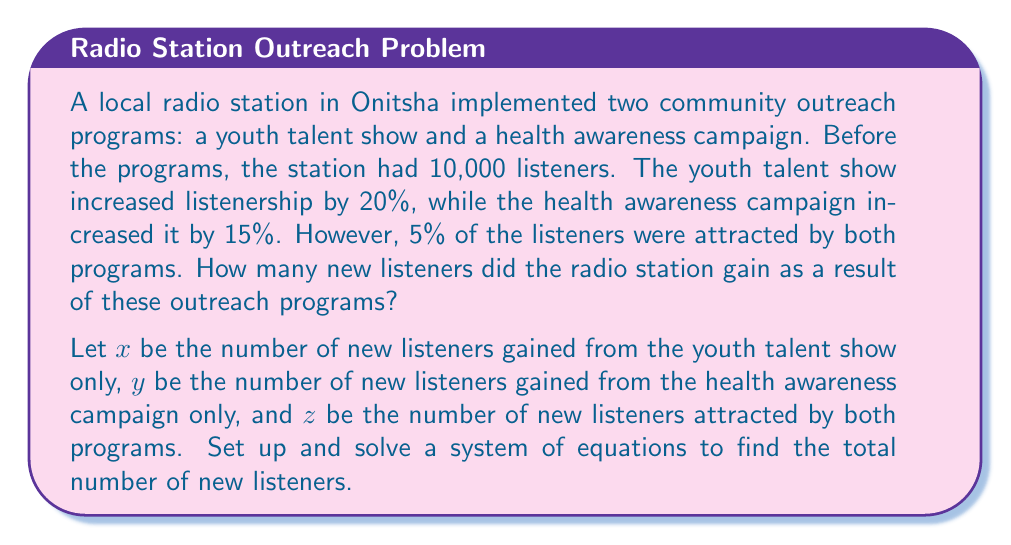Show me your answer to this math problem. Let's approach this problem step by step:

1) First, let's set up our equations based on the given information:

   $x + z = 0.20 \times 10,000 = 2,000$ (Youth talent show)
   $y + z = 0.15 \times 10,000 = 1,500$ (Health awareness campaign)
   $z = 0.05 \times 10,000 = 500$ (Listeners attracted by both programs)

2) Now we have a system of three equations with three unknowns:

   $$\begin{cases}
   x + z = 2,000 \\
   y + z = 1,500 \\
   z = 500
   \end{cases}$$

3) We can solve this system by substitution. Let's start by substituting the value of $z$ into the first two equations:

   $$\begin{cases}
   x + 500 = 2,000 \\
   y + 500 = 1,500 \\
   z = 500
   \end{cases}$$

4) Now we can solve for $x$ and $y$:

   $x = 2,000 - 500 = 1,500$
   $y = 1,500 - 500 = 1,000$

5) We now have the values for $x$, $y$, and $z$:

   $x = 1,500$ (new listeners from youth talent show only)
   $y = 1,000$ (new listeners from health awareness campaign only)
   $z = 500$ (new listeners attracted by both programs)

6) To find the total number of new listeners, we sum these values:

   Total new listeners = $x + y + z = 1,500 + 1,000 + 500 = 3,000$

Therefore, the radio station gained 3,000 new listeners as a result of these outreach programs.
Answer: 3,000 new listeners 